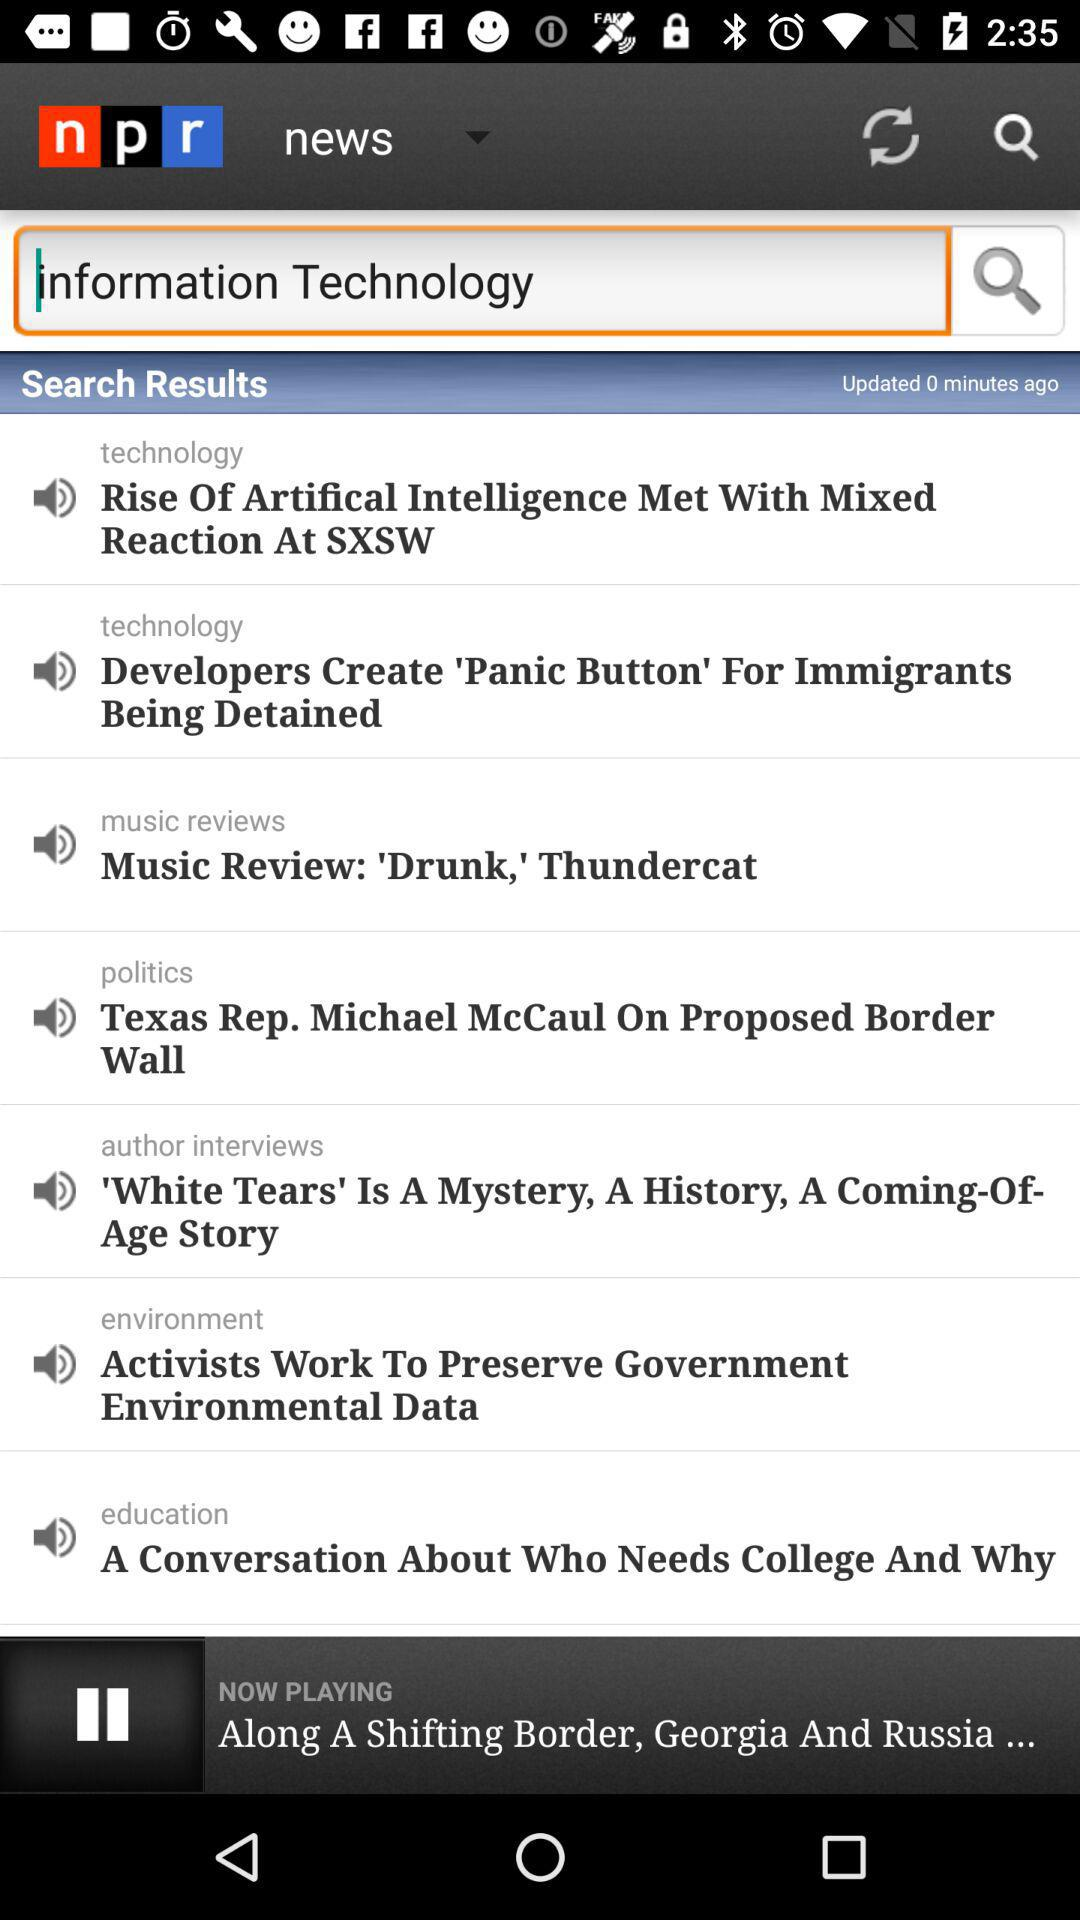What is the name of the application? The name of the application is "npr". 